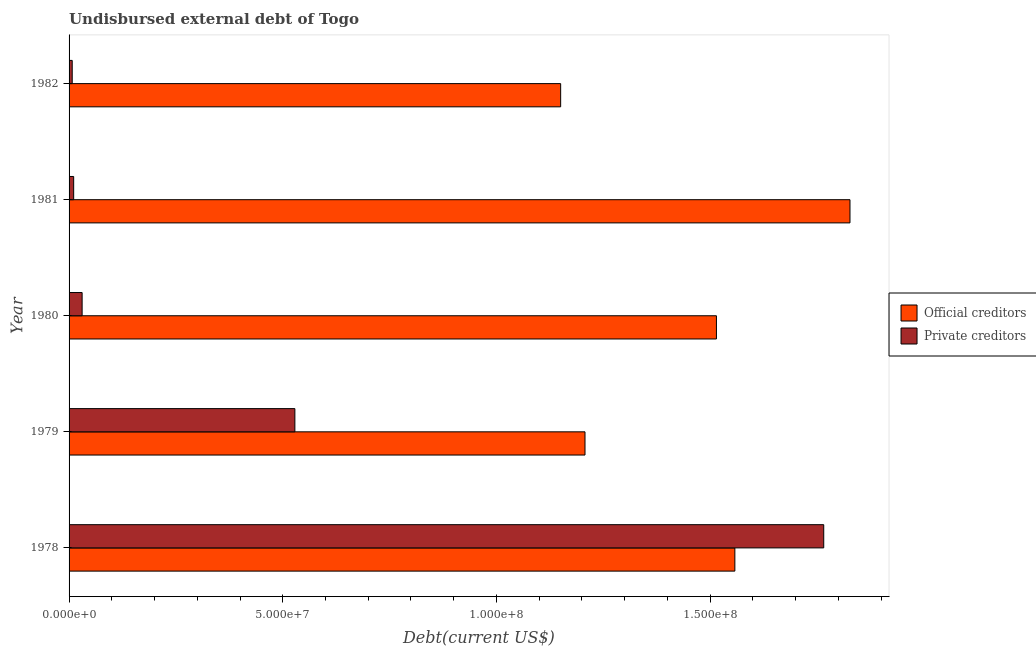How many different coloured bars are there?
Ensure brevity in your answer.  2. How many groups of bars are there?
Your answer should be very brief. 5. Are the number of bars on each tick of the Y-axis equal?
Provide a succinct answer. Yes. How many bars are there on the 4th tick from the top?
Offer a very short reply. 2. How many bars are there on the 4th tick from the bottom?
Your response must be concise. 2. What is the label of the 5th group of bars from the top?
Ensure brevity in your answer.  1978. What is the undisbursed external debt of official creditors in 1979?
Provide a short and direct response. 1.21e+08. Across all years, what is the maximum undisbursed external debt of official creditors?
Your answer should be compact. 1.83e+08. Across all years, what is the minimum undisbursed external debt of official creditors?
Make the answer very short. 1.15e+08. In which year was the undisbursed external debt of private creditors maximum?
Provide a succinct answer. 1978. In which year was the undisbursed external debt of official creditors minimum?
Offer a very short reply. 1982. What is the total undisbursed external debt of private creditors in the graph?
Keep it short and to the point. 2.34e+08. What is the difference between the undisbursed external debt of official creditors in 1978 and that in 1982?
Provide a succinct answer. 4.08e+07. What is the difference between the undisbursed external debt of private creditors in 1979 and the undisbursed external debt of official creditors in 1978?
Provide a short and direct response. -1.03e+08. What is the average undisbursed external debt of private creditors per year?
Make the answer very short. 4.69e+07. In the year 1979, what is the difference between the undisbursed external debt of official creditors and undisbursed external debt of private creditors?
Keep it short and to the point. 6.79e+07. In how many years, is the undisbursed external debt of private creditors greater than 90000000 US$?
Make the answer very short. 1. What is the ratio of the undisbursed external debt of private creditors in 1979 to that in 1980?
Ensure brevity in your answer.  17.3. What is the difference between the highest and the second highest undisbursed external debt of official creditors?
Your answer should be compact. 2.69e+07. What is the difference between the highest and the lowest undisbursed external debt of private creditors?
Your answer should be compact. 1.76e+08. In how many years, is the undisbursed external debt of private creditors greater than the average undisbursed external debt of private creditors taken over all years?
Make the answer very short. 2. What does the 1st bar from the top in 1978 represents?
Provide a short and direct response. Private creditors. What does the 1st bar from the bottom in 1979 represents?
Your response must be concise. Official creditors. How many bars are there?
Provide a succinct answer. 10. Are all the bars in the graph horizontal?
Your answer should be compact. Yes. What is the difference between two consecutive major ticks on the X-axis?
Make the answer very short. 5.00e+07. Are the values on the major ticks of X-axis written in scientific E-notation?
Ensure brevity in your answer.  Yes. Does the graph contain grids?
Make the answer very short. No. Where does the legend appear in the graph?
Offer a very short reply. Center right. What is the title of the graph?
Make the answer very short. Undisbursed external debt of Togo. What is the label or title of the X-axis?
Make the answer very short. Debt(current US$). What is the label or title of the Y-axis?
Offer a very short reply. Year. What is the Debt(current US$) of Official creditors in 1978?
Your response must be concise. 1.56e+08. What is the Debt(current US$) of Private creditors in 1978?
Make the answer very short. 1.77e+08. What is the Debt(current US$) in Official creditors in 1979?
Make the answer very short. 1.21e+08. What is the Debt(current US$) in Private creditors in 1979?
Offer a terse response. 5.28e+07. What is the Debt(current US$) in Official creditors in 1980?
Provide a short and direct response. 1.51e+08. What is the Debt(current US$) in Private creditors in 1980?
Provide a short and direct response. 3.05e+06. What is the Debt(current US$) in Official creditors in 1981?
Make the answer very short. 1.83e+08. What is the Debt(current US$) in Private creditors in 1981?
Your response must be concise. 1.08e+06. What is the Debt(current US$) of Official creditors in 1982?
Offer a terse response. 1.15e+08. What is the Debt(current US$) in Private creditors in 1982?
Make the answer very short. 7.35e+05. Across all years, what is the maximum Debt(current US$) in Official creditors?
Your response must be concise. 1.83e+08. Across all years, what is the maximum Debt(current US$) in Private creditors?
Your response must be concise. 1.77e+08. Across all years, what is the minimum Debt(current US$) in Official creditors?
Offer a terse response. 1.15e+08. Across all years, what is the minimum Debt(current US$) of Private creditors?
Keep it short and to the point. 7.35e+05. What is the total Debt(current US$) in Official creditors in the graph?
Your response must be concise. 7.26e+08. What is the total Debt(current US$) of Private creditors in the graph?
Your response must be concise. 2.34e+08. What is the difference between the Debt(current US$) in Official creditors in 1978 and that in 1979?
Give a very brief answer. 3.51e+07. What is the difference between the Debt(current US$) in Private creditors in 1978 and that in 1979?
Give a very brief answer. 1.24e+08. What is the difference between the Debt(current US$) of Official creditors in 1978 and that in 1980?
Keep it short and to the point. 4.31e+06. What is the difference between the Debt(current US$) of Private creditors in 1978 and that in 1980?
Make the answer very short. 1.74e+08. What is the difference between the Debt(current US$) in Official creditors in 1978 and that in 1981?
Offer a terse response. -2.69e+07. What is the difference between the Debt(current US$) of Private creditors in 1978 and that in 1981?
Your response must be concise. 1.76e+08. What is the difference between the Debt(current US$) in Official creditors in 1978 and that in 1982?
Give a very brief answer. 4.08e+07. What is the difference between the Debt(current US$) of Private creditors in 1978 and that in 1982?
Offer a very short reply. 1.76e+08. What is the difference between the Debt(current US$) in Official creditors in 1979 and that in 1980?
Offer a very short reply. -3.08e+07. What is the difference between the Debt(current US$) in Private creditors in 1979 and that in 1980?
Your answer should be very brief. 4.98e+07. What is the difference between the Debt(current US$) in Official creditors in 1979 and that in 1981?
Offer a terse response. -6.20e+07. What is the difference between the Debt(current US$) in Private creditors in 1979 and that in 1981?
Make the answer very short. 5.18e+07. What is the difference between the Debt(current US$) in Official creditors in 1979 and that in 1982?
Ensure brevity in your answer.  5.70e+06. What is the difference between the Debt(current US$) of Private creditors in 1979 and that in 1982?
Your response must be concise. 5.21e+07. What is the difference between the Debt(current US$) in Official creditors in 1980 and that in 1981?
Offer a very short reply. -3.12e+07. What is the difference between the Debt(current US$) in Private creditors in 1980 and that in 1981?
Offer a terse response. 1.98e+06. What is the difference between the Debt(current US$) of Official creditors in 1980 and that in 1982?
Make the answer very short. 3.65e+07. What is the difference between the Debt(current US$) in Private creditors in 1980 and that in 1982?
Your response must be concise. 2.32e+06. What is the difference between the Debt(current US$) of Official creditors in 1981 and that in 1982?
Your answer should be very brief. 6.77e+07. What is the difference between the Debt(current US$) of Private creditors in 1981 and that in 1982?
Your response must be concise. 3.42e+05. What is the difference between the Debt(current US$) in Official creditors in 1978 and the Debt(current US$) in Private creditors in 1979?
Your response must be concise. 1.03e+08. What is the difference between the Debt(current US$) in Official creditors in 1978 and the Debt(current US$) in Private creditors in 1980?
Make the answer very short. 1.53e+08. What is the difference between the Debt(current US$) in Official creditors in 1978 and the Debt(current US$) in Private creditors in 1981?
Offer a terse response. 1.55e+08. What is the difference between the Debt(current US$) in Official creditors in 1978 and the Debt(current US$) in Private creditors in 1982?
Provide a short and direct response. 1.55e+08. What is the difference between the Debt(current US$) in Official creditors in 1979 and the Debt(current US$) in Private creditors in 1980?
Your answer should be compact. 1.18e+08. What is the difference between the Debt(current US$) in Official creditors in 1979 and the Debt(current US$) in Private creditors in 1981?
Ensure brevity in your answer.  1.20e+08. What is the difference between the Debt(current US$) of Official creditors in 1979 and the Debt(current US$) of Private creditors in 1982?
Ensure brevity in your answer.  1.20e+08. What is the difference between the Debt(current US$) in Official creditors in 1980 and the Debt(current US$) in Private creditors in 1981?
Your answer should be very brief. 1.50e+08. What is the difference between the Debt(current US$) in Official creditors in 1980 and the Debt(current US$) in Private creditors in 1982?
Your response must be concise. 1.51e+08. What is the difference between the Debt(current US$) of Official creditors in 1981 and the Debt(current US$) of Private creditors in 1982?
Give a very brief answer. 1.82e+08. What is the average Debt(current US$) of Official creditors per year?
Keep it short and to the point. 1.45e+08. What is the average Debt(current US$) in Private creditors per year?
Make the answer very short. 4.69e+07. In the year 1978, what is the difference between the Debt(current US$) of Official creditors and Debt(current US$) of Private creditors?
Offer a very short reply. -2.08e+07. In the year 1979, what is the difference between the Debt(current US$) in Official creditors and Debt(current US$) in Private creditors?
Provide a short and direct response. 6.79e+07. In the year 1980, what is the difference between the Debt(current US$) of Official creditors and Debt(current US$) of Private creditors?
Keep it short and to the point. 1.48e+08. In the year 1981, what is the difference between the Debt(current US$) of Official creditors and Debt(current US$) of Private creditors?
Keep it short and to the point. 1.82e+08. In the year 1982, what is the difference between the Debt(current US$) in Official creditors and Debt(current US$) in Private creditors?
Keep it short and to the point. 1.14e+08. What is the ratio of the Debt(current US$) in Official creditors in 1978 to that in 1979?
Offer a very short reply. 1.29. What is the ratio of the Debt(current US$) in Private creditors in 1978 to that in 1979?
Give a very brief answer. 3.34. What is the ratio of the Debt(current US$) in Official creditors in 1978 to that in 1980?
Provide a short and direct response. 1.03. What is the ratio of the Debt(current US$) of Private creditors in 1978 to that in 1980?
Your answer should be very brief. 57.83. What is the ratio of the Debt(current US$) of Official creditors in 1978 to that in 1981?
Keep it short and to the point. 0.85. What is the ratio of the Debt(current US$) of Private creditors in 1978 to that in 1981?
Your answer should be very brief. 163.97. What is the ratio of the Debt(current US$) of Official creditors in 1978 to that in 1982?
Your response must be concise. 1.35. What is the ratio of the Debt(current US$) in Private creditors in 1978 to that in 1982?
Provide a succinct answer. 240.27. What is the ratio of the Debt(current US$) of Official creditors in 1979 to that in 1980?
Ensure brevity in your answer.  0.8. What is the ratio of the Debt(current US$) of Private creditors in 1979 to that in 1980?
Provide a succinct answer. 17.3. What is the ratio of the Debt(current US$) of Official creditors in 1979 to that in 1981?
Your response must be concise. 0.66. What is the ratio of the Debt(current US$) of Private creditors in 1979 to that in 1981?
Provide a short and direct response. 49.06. What is the ratio of the Debt(current US$) of Official creditors in 1979 to that in 1982?
Offer a terse response. 1.05. What is the ratio of the Debt(current US$) in Private creditors in 1979 to that in 1982?
Make the answer very short. 71.89. What is the ratio of the Debt(current US$) in Official creditors in 1980 to that in 1981?
Keep it short and to the point. 0.83. What is the ratio of the Debt(current US$) in Private creditors in 1980 to that in 1981?
Your answer should be compact. 2.84. What is the ratio of the Debt(current US$) of Official creditors in 1980 to that in 1982?
Ensure brevity in your answer.  1.32. What is the ratio of the Debt(current US$) of Private creditors in 1980 to that in 1982?
Keep it short and to the point. 4.16. What is the ratio of the Debt(current US$) of Official creditors in 1981 to that in 1982?
Your answer should be very brief. 1.59. What is the ratio of the Debt(current US$) of Private creditors in 1981 to that in 1982?
Provide a short and direct response. 1.47. What is the difference between the highest and the second highest Debt(current US$) in Official creditors?
Ensure brevity in your answer.  2.69e+07. What is the difference between the highest and the second highest Debt(current US$) of Private creditors?
Give a very brief answer. 1.24e+08. What is the difference between the highest and the lowest Debt(current US$) of Official creditors?
Provide a succinct answer. 6.77e+07. What is the difference between the highest and the lowest Debt(current US$) of Private creditors?
Give a very brief answer. 1.76e+08. 